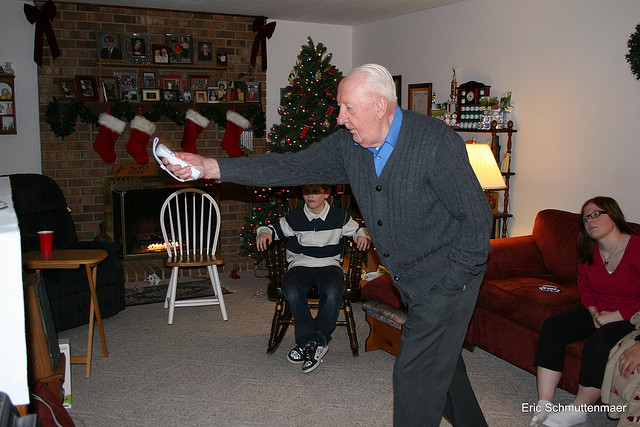Please extract the text content from this image. Schmuttenmaer Eric 